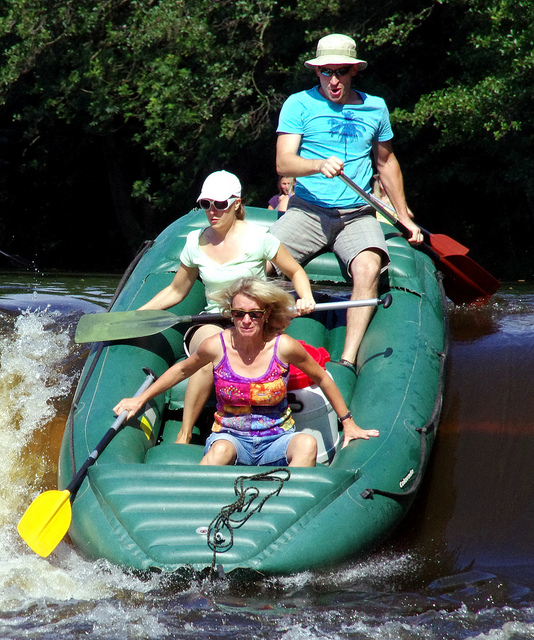What sort of equipment do people usually need for this kind of water activity? For water activities like whitewater rafting, individuals typically require a raft suited for rapids, personal flotation devices (life jackets) for safety, helmets to protect from any impacts, and paddles for maneuvering. Clothing that dries quickly and water shoes are also commonly worn for comfort and protection. 